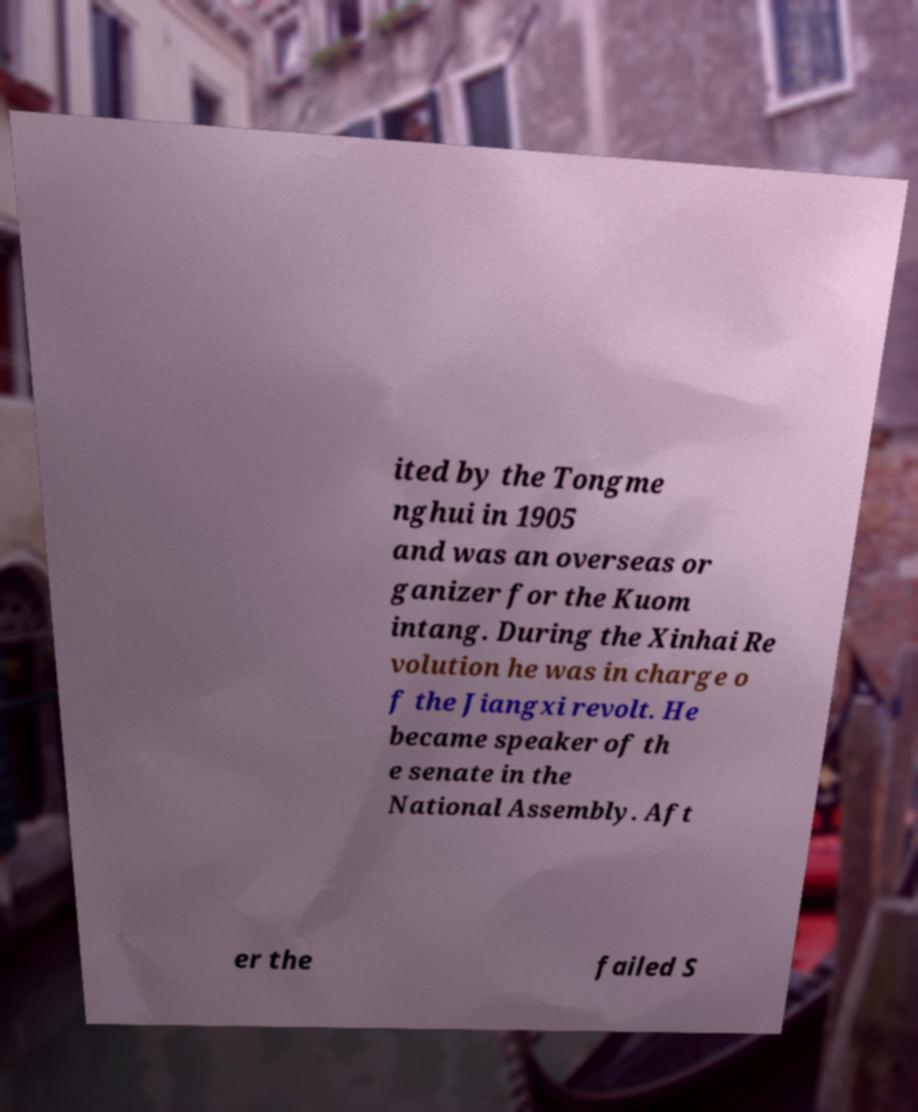Please identify and transcribe the text found in this image. ited by the Tongme nghui in 1905 and was an overseas or ganizer for the Kuom intang. During the Xinhai Re volution he was in charge o f the Jiangxi revolt. He became speaker of th e senate in the National Assembly. Aft er the failed S 